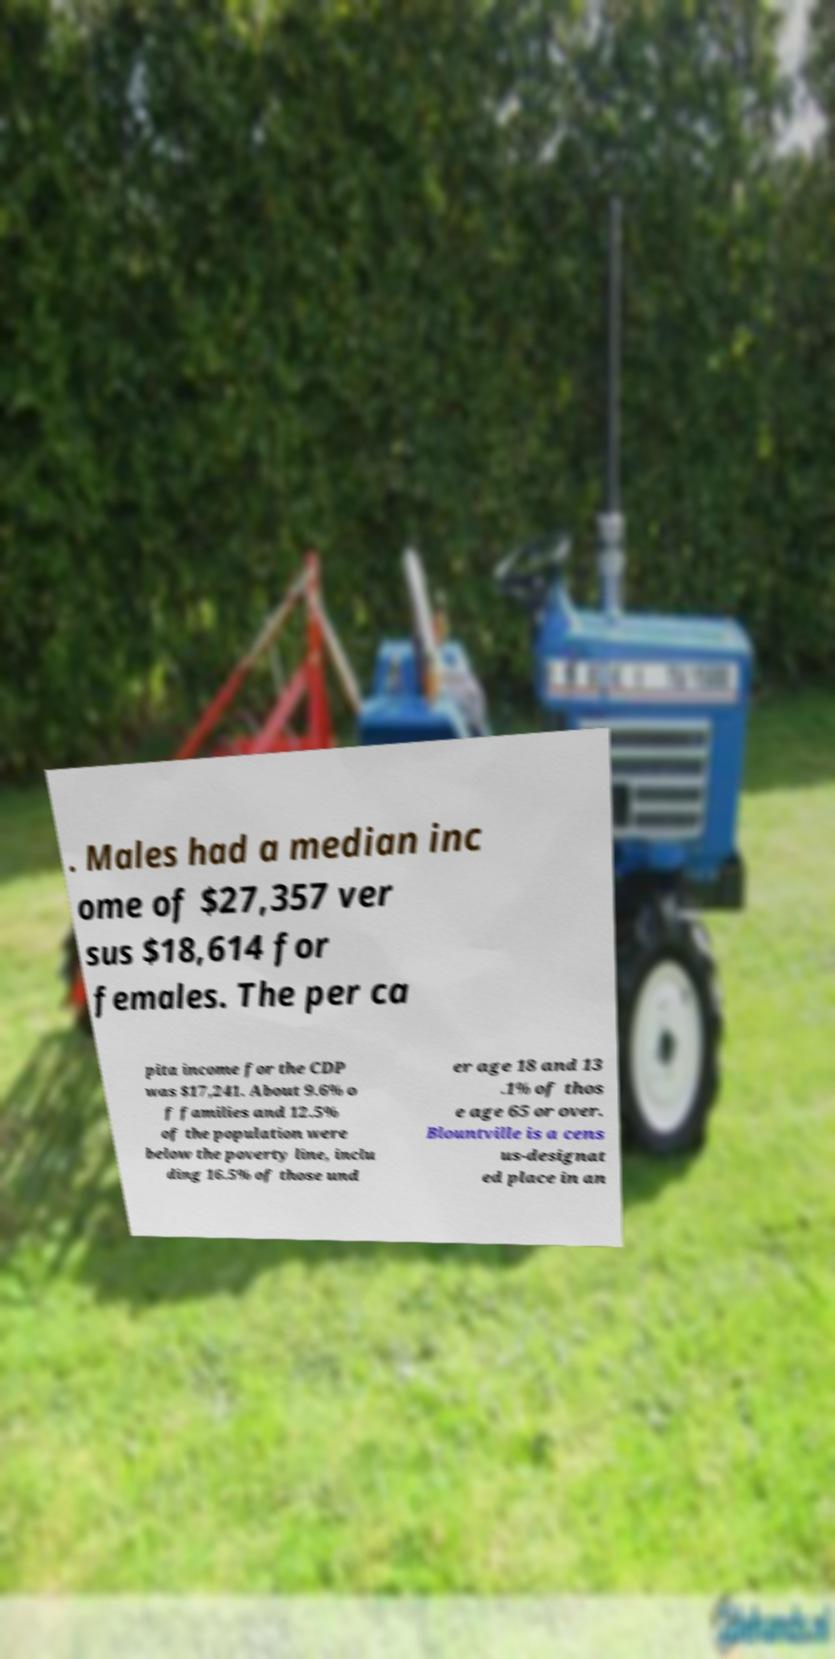There's text embedded in this image that I need extracted. Can you transcribe it verbatim? . Males had a median inc ome of $27,357 ver sus $18,614 for females. The per ca pita income for the CDP was $17,241. About 9.6% o f families and 12.5% of the population were below the poverty line, inclu ding 16.5% of those und er age 18 and 13 .1% of thos e age 65 or over. Blountville is a cens us-designat ed place in an 